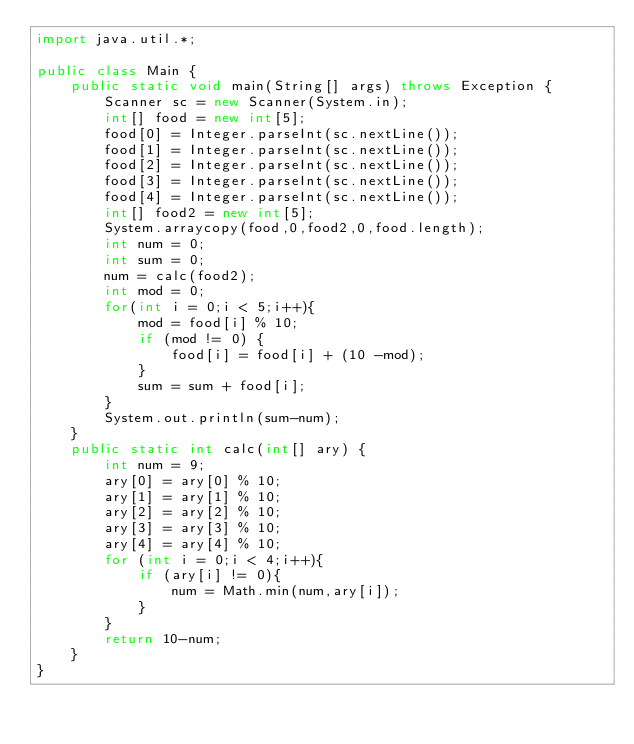Convert code to text. <code><loc_0><loc_0><loc_500><loc_500><_Java_>import java.util.*;

public class Main {
    public static void main(String[] args) throws Exception {
        Scanner sc = new Scanner(System.in);
        int[] food = new int[5];
        food[0] = Integer.parseInt(sc.nextLine());
        food[1] = Integer.parseInt(sc.nextLine());
        food[2] = Integer.parseInt(sc.nextLine());
        food[3] = Integer.parseInt(sc.nextLine());
        food[4] = Integer.parseInt(sc.nextLine());
        int[] food2 = new int[5];
        System.arraycopy(food,0,food2,0,food.length);
        int num = 0;
        int sum = 0;
        num = calc(food2);
        int mod = 0;
        for(int i = 0;i < 5;i++){
            mod = food[i] % 10;
            if (mod != 0) {
                food[i] = food[i] + (10 -mod);
            }
            sum = sum + food[i];
        }
        System.out.println(sum-num);
    }
    public static int calc(int[] ary) {
        int num = 9;
        ary[0] = ary[0] % 10;
        ary[1] = ary[1] % 10;
        ary[2] = ary[2] % 10;
        ary[3] = ary[3] % 10;
        ary[4] = ary[4] % 10;
        for (int i = 0;i < 4;i++){
            if (ary[i] != 0){
                num = Math.min(num,ary[i]);
            }
        }
        return 10-num;
    }
}
</code> 